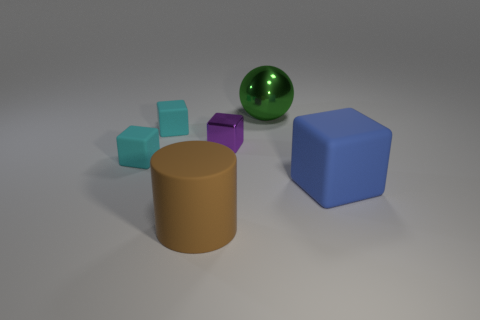What color is the cylinder that is the same size as the green ball? brown 